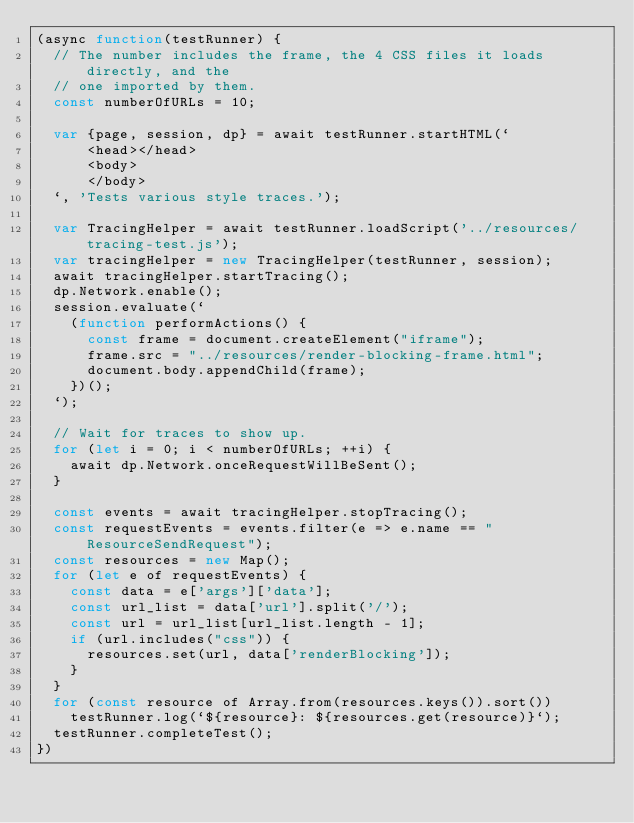<code> <loc_0><loc_0><loc_500><loc_500><_JavaScript_>(async function(testRunner) {
  // The number includes the frame, the 4 CSS files it loads directly, and the
  // one imported by them.
  const numberOfURLs = 10;

  var {page, session, dp} = await testRunner.startHTML(`
      <head></head>
      <body>
      </body>
  `, 'Tests various style traces.');

  var TracingHelper = await testRunner.loadScript('../resources/tracing-test.js');
  var tracingHelper = new TracingHelper(testRunner, session);
  await tracingHelper.startTracing();
  dp.Network.enable();
  session.evaluate(`
    (function performActions() {
      const frame = document.createElement("iframe");
      frame.src = "../resources/render-blocking-frame.html";
      document.body.appendChild(frame);
    })();
  `);

  // Wait for traces to show up.
  for (let i = 0; i < numberOfURLs; ++i) {
    await dp.Network.onceRequestWillBeSent();
  }

  const events = await tracingHelper.stopTracing();
  const requestEvents = events.filter(e => e.name == "ResourceSendRequest");
  const resources = new Map();
  for (let e of requestEvents) {
    const data = e['args']['data'];
    const url_list = data['url'].split('/');
    const url = url_list[url_list.length - 1];
    if (url.includes("css")) {
      resources.set(url, data['renderBlocking']);
    }
  }
  for (const resource of Array.from(resources.keys()).sort())
    testRunner.log(`${resource}: ${resources.get(resource)}`);
  testRunner.completeTest();
})
</code> 